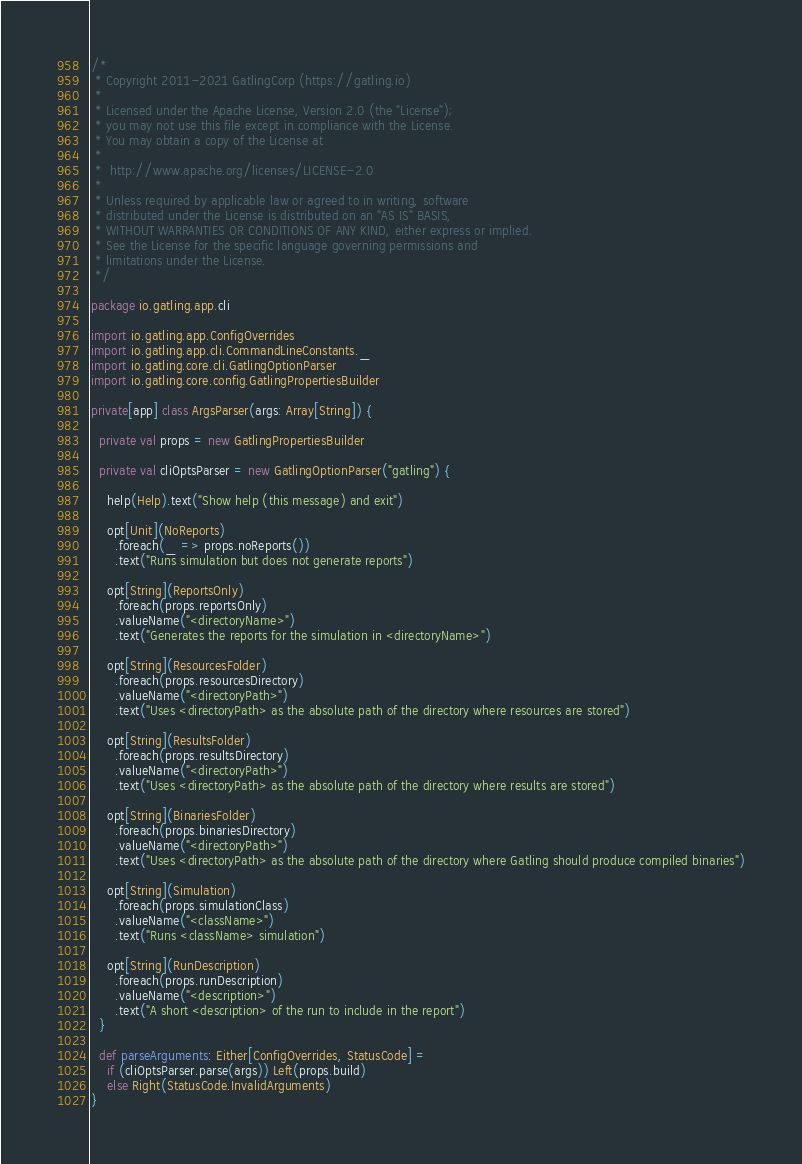<code> <loc_0><loc_0><loc_500><loc_500><_Scala_>/*
 * Copyright 2011-2021 GatlingCorp (https://gatling.io)
 *
 * Licensed under the Apache License, Version 2.0 (the "License");
 * you may not use this file except in compliance with the License.
 * You may obtain a copy of the License at
 *
 *  http://www.apache.org/licenses/LICENSE-2.0
 *
 * Unless required by applicable law or agreed to in writing, software
 * distributed under the License is distributed on an "AS IS" BASIS,
 * WITHOUT WARRANTIES OR CONDITIONS OF ANY KIND, either express or implied.
 * See the License for the specific language governing permissions and
 * limitations under the License.
 */

package io.gatling.app.cli

import io.gatling.app.ConfigOverrides
import io.gatling.app.cli.CommandLineConstants._
import io.gatling.core.cli.GatlingOptionParser
import io.gatling.core.config.GatlingPropertiesBuilder

private[app] class ArgsParser(args: Array[String]) {

  private val props = new GatlingPropertiesBuilder

  private val cliOptsParser = new GatlingOptionParser("gatling") {

    help(Help).text("Show help (this message) and exit")

    opt[Unit](NoReports)
      .foreach(_ => props.noReports())
      .text("Runs simulation but does not generate reports")

    opt[String](ReportsOnly)
      .foreach(props.reportsOnly)
      .valueName("<directoryName>")
      .text("Generates the reports for the simulation in <directoryName>")

    opt[String](ResourcesFolder)
      .foreach(props.resourcesDirectory)
      .valueName("<directoryPath>")
      .text("Uses <directoryPath> as the absolute path of the directory where resources are stored")

    opt[String](ResultsFolder)
      .foreach(props.resultsDirectory)
      .valueName("<directoryPath>")
      .text("Uses <directoryPath> as the absolute path of the directory where results are stored")

    opt[String](BinariesFolder)
      .foreach(props.binariesDirectory)
      .valueName("<directoryPath>")
      .text("Uses <directoryPath> as the absolute path of the directory where Gatling should produce compiled binaries")

    opt[String](Simulation)
      .foreach(props.simulationClass)
      .valueName("<className>")
      .text("Runs <className> simulation")

    opt[String](RunDescription)
      .foreach(props.runDescription)
      .valueName("<description>")
      .text("A short <description> of the run to include in the report")
  }

  def parseArguments: Either[ConfigOverrides, StatusCode] =
    if (cliOptsParser.parse(args)) Left(props.build)
    else Right(StatusCode.InvalidArguments)
}
</code> 